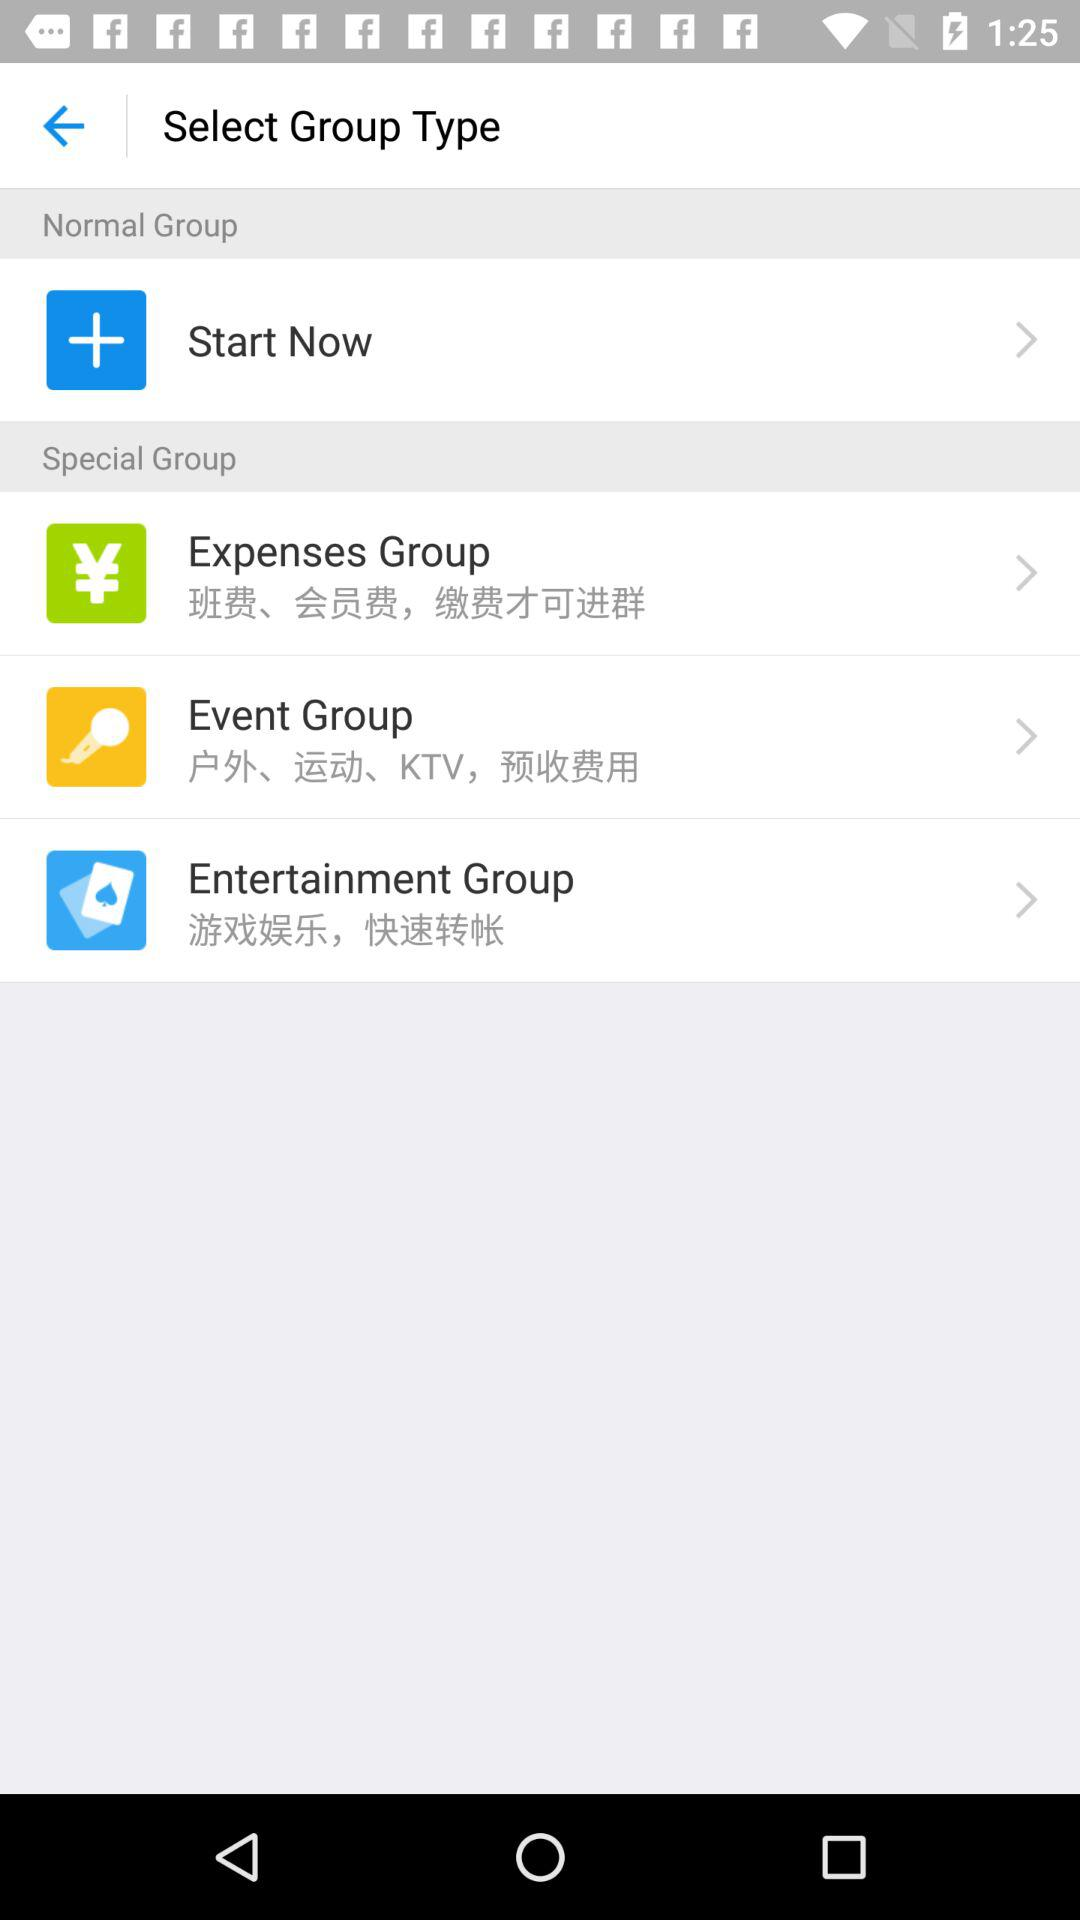How many groups are there in total?
Answer the question using a single word or phrase. 4 